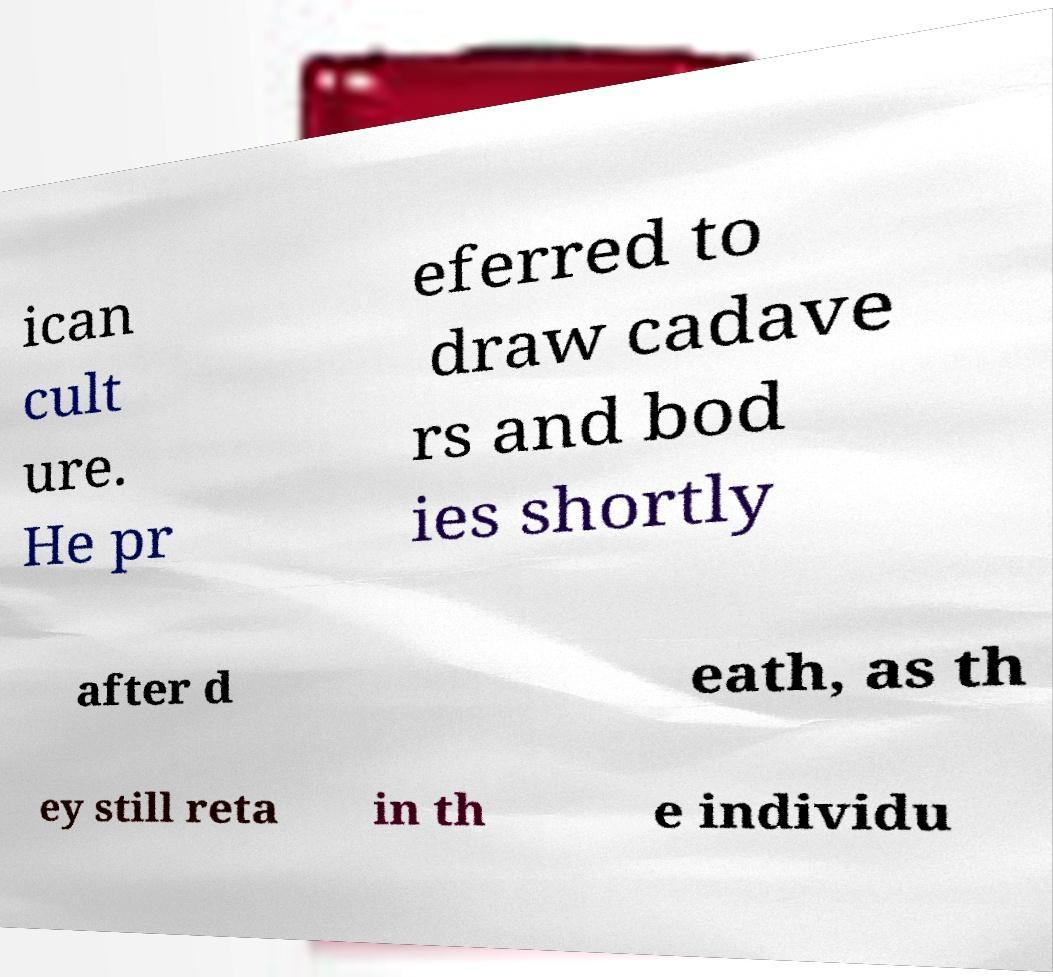Can you accurately transcribe the text from the provided image for me? ican cult ure. He pr eferred to draw cadave rs and bod ies shortly after d eath, as th ey still reta in th e individu 